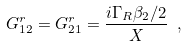<formula> <loc_0><loc_0><loc_500><loc_500>G ^ { r } _ { 1 2 } = G ^ { r } _ { 2 1 } = \frac { i \Gamma _ { R } \beta _ { 2 } / 2 } { X } \ ,</formula> 